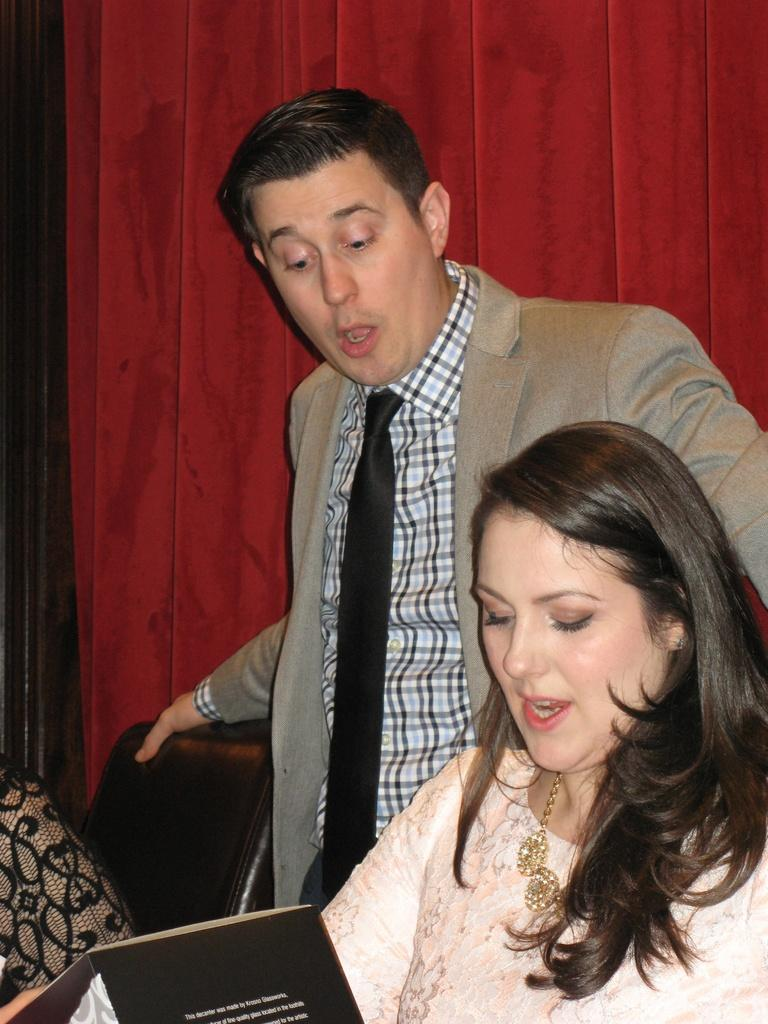What is the man in the image doing? The man is standing and holding a chair. What is the woman in the image doing? The woman is holding a magazine and watching it. What can be seen in the background of the image? There is a wall in the background of the image. What type of bread is being served in the morning in the image? There is no bread or morning scene present in the image. How long has the woman been resting in the image? The woman is not resting in the image; she is holding a magazine and watching it. 